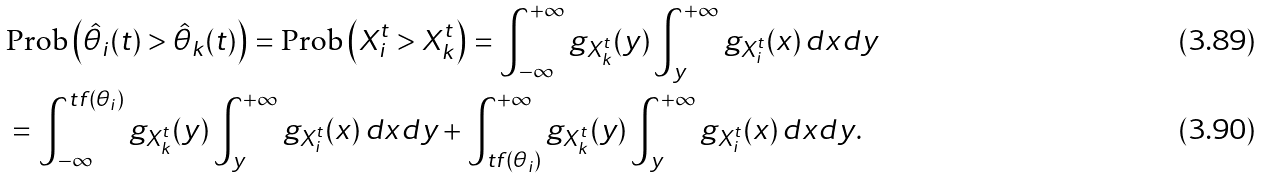Convert formula to latex. <formula><loc_0><loc_0><loc_500><loc_500>& \text {Prob} \left ( \hat { \theta } _ { i } ( t ) > \hat { \theta } _ { k } ( t ) \right ) = \text {Prob} \left ( X _ { i } ^ { t } > X _ { k } ^ { t } \right ) = \int _ { - \infty } ^ { + \infty } g _ { X _ { k } ^ { t } } ( y ) \int _ { y } ^ { + \infty } g _ { X _ { i } ^ { t } } ( x ) \, d x d y \\ & = \int _ { - \infty } ^ { t f ( \theta _ { i } ) } g _ { X _ { k } ^ { t } } ( y ) \int _ { y } ^ { + \infty } g _ { X _ { i } ^ { t } } ( x ) \, d x d y + \int _ { t f ( \theta _ { i } ) } ^ { + \infty } g _ { X _ { k } ^ { t } } ( y ) \int _ { y } ^ { + \infty } g _ { X _ { i } ^ { t } } ( x ) \, d x d y .</formula> 